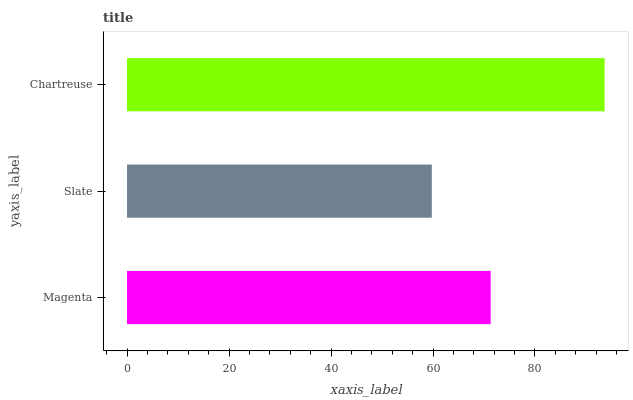Is Slate the minimum?
Answer yes or no. Yes. Is Chartreuse the maximum?
Answer yes or no. Yes. Is Chartreuse the minimum?
Answer yes or no. No. Is Slate the maximum?
Answer yes or no. No. Is Chartreuse greater than Slate?
Answer yes or no. Yes. Is Slate less than Chartreuse?
Answer yes or no. Yes. Is Slate greater than Chartreuse?
Answer yes or no. No. Is Chartreuse less than Slate?
Answer yes or no. No. Is Magenta the high median?
Answer yes or no. Yes. Is Magenta the low median?
Answer yes or no. Yes. Is Chartreuse the high median?
Answer yes or no. No. Is Slate the low median?
Answer yes or no. No. 